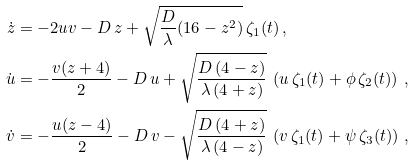<formula> <loc_0><loc_0><loc_500><loc_500>\dot { z } & = - 2 u v - D \, z + \sqrt { \frac { D } { \lambda } ( 1 6 - z ^ { 2 } ) } \, \zeta _ { 1 } ( t ) \, , \\ \dot { u } & = - \frac { v ( z + 4 ) } { 2 } - D \, u + \sqrt { \frac { D \, ( 4 - z ) } { \lambda \, ( 4 + z ) } } \, \left ( u \, \zeta _ { 1 } ( t ) + \phi \, \zeta _ { 2 } ( t ) \right ) \, , \\ \dot { v } & = - \frac { u ( z - 4 ) } { 2 } - D \, v - \sqrt { \frac { D \, ( 4 + z ) } { \lambda \, ( 4 - z ) } } \, \left ( v \, \zeta _ { 1 } ( t ) + \psi \, \zeta _ { 3 } ( t ) \right ) \, ,</formula> 